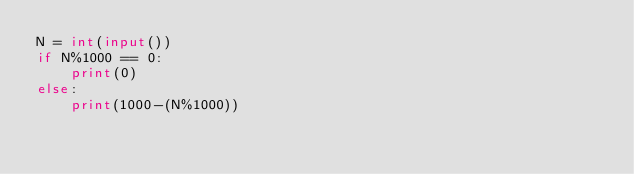<code> <loc_0><loc_0><loc_500><loc_500><_Python_>N = int(input())
if N%1000 == 0:
    print(0)
else:
    print(1000-(N%1000))</code> 